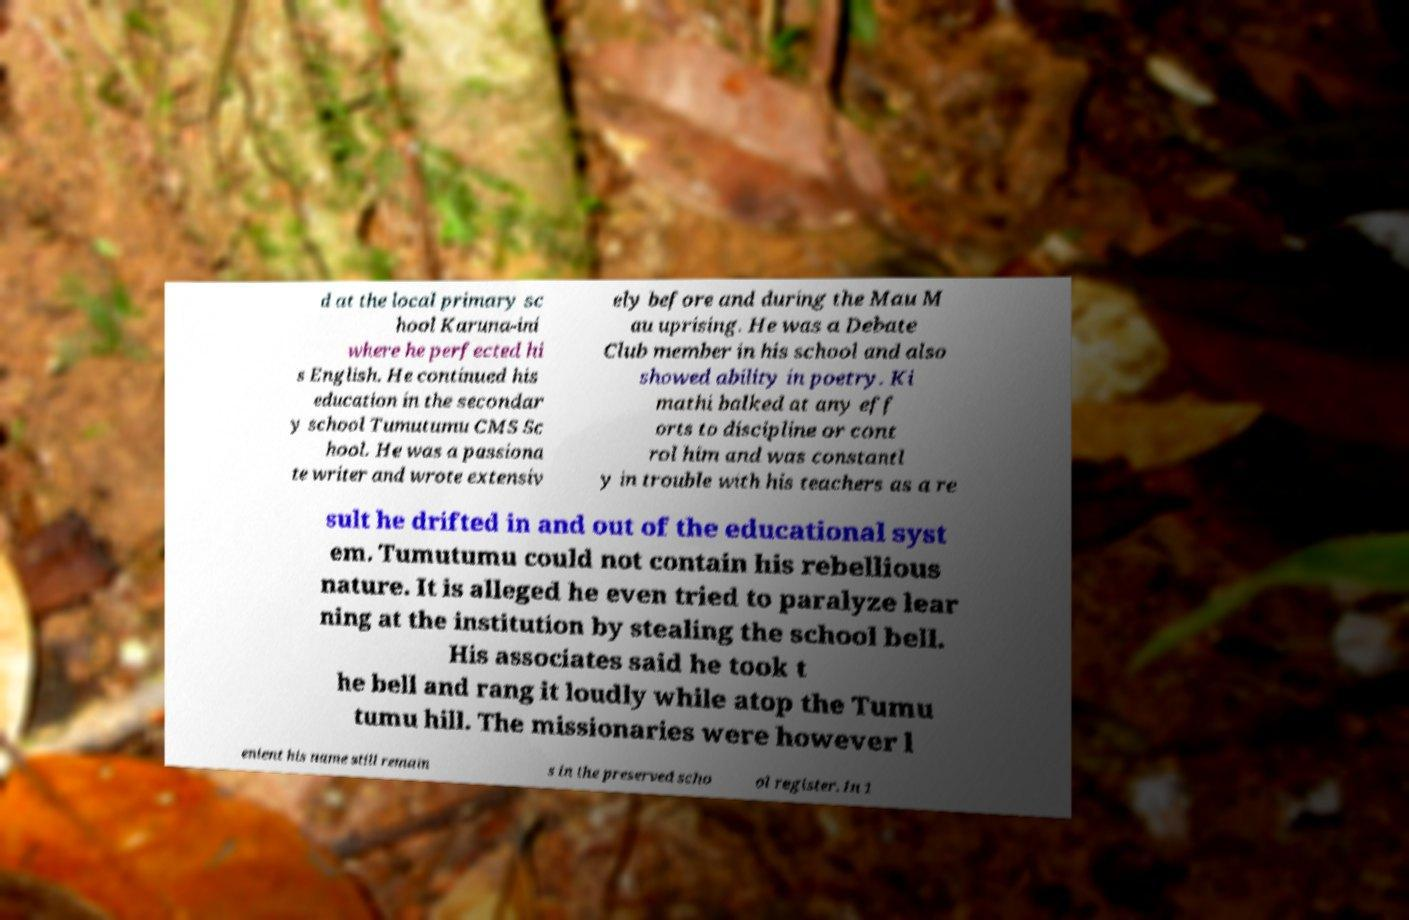Can you read and provide the text displayed in the image?This photo seems to have some interesting text. Can you extract and type it out for me? d at the local primary sc hool Karuna-ini where he perfected hi s English. He continued his education in the secondar y school Tumutumu CMS Sc hool. He was a passiona te writer and wrote extensiv ely before and during the Mau M au uprising. He was a Debate Club member in his school and also showed ability in poetry. Ki mathi balked at any eff orts to discipline or cont rol him and was constantl y in trouble with his teachers as a re sult he drifted in and out of the educational syst em. Tumutumu could not contain his rebellious nature. It is alleged he even tried to paralyze lear ning at the institution by stealing the school bell. His associates said he took t he bell and rang it loudly while atop the Tumu tumu hill. The missionaries were however l enient his name still remain s in the preserved scho ol register. In 1 